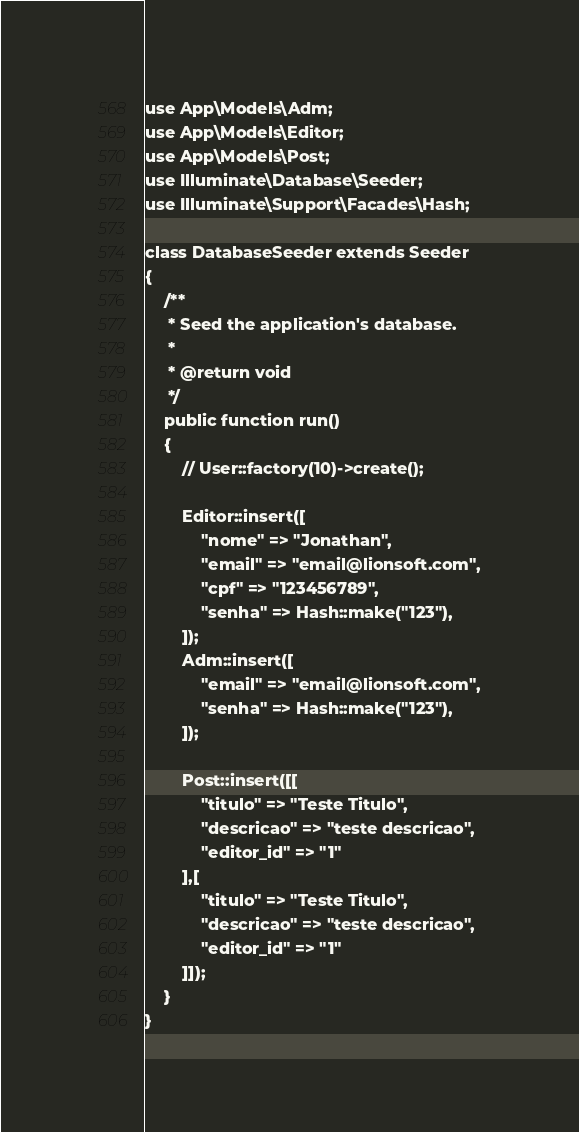<code> <loc_0><loc_0><loc_500><loc_500><_PHP_>use App\Models\Adm;
use App\Models\Editor;
use App\Models\Post;
use Illuminate\Database\Seeder;
use Illuminate\Support\Facades\Hash;

class DatabaseSeeder extends Seeder
{
    /**
     * Seed the application's database.
     *
     * @return void
     */
    public function run()
    {
        // User::factory(10)->create();

        Editor::insert([
            "nome" => "Jonathan",
            "email" => "email@lionsoft.com",
            "cpf" => "123456789",
            "senha" => Hash::make("123"),
        ]);
        Adm::insert([
            "email" => "email@lionsoft.com",
            "senha" => Hash::make("123"),
        ]);

        Post::insert([[
            "titulo" => "Teste Titulo",
            "descricao" => "teste descricao",
            "editor_id" => "1"
        ],[
            "titulo" => "Teste Titulo",
            "descricao" => "teste descricao",
            "editor_id" => "1"
        ]]);
    }
}
</code> 